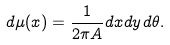<formula> <loc_0><loc_0><loc_500><loc_500>d \mu ( x ) = \frac { 1 } { 2 \pi A } d x d y \, d \theta .</formula> 